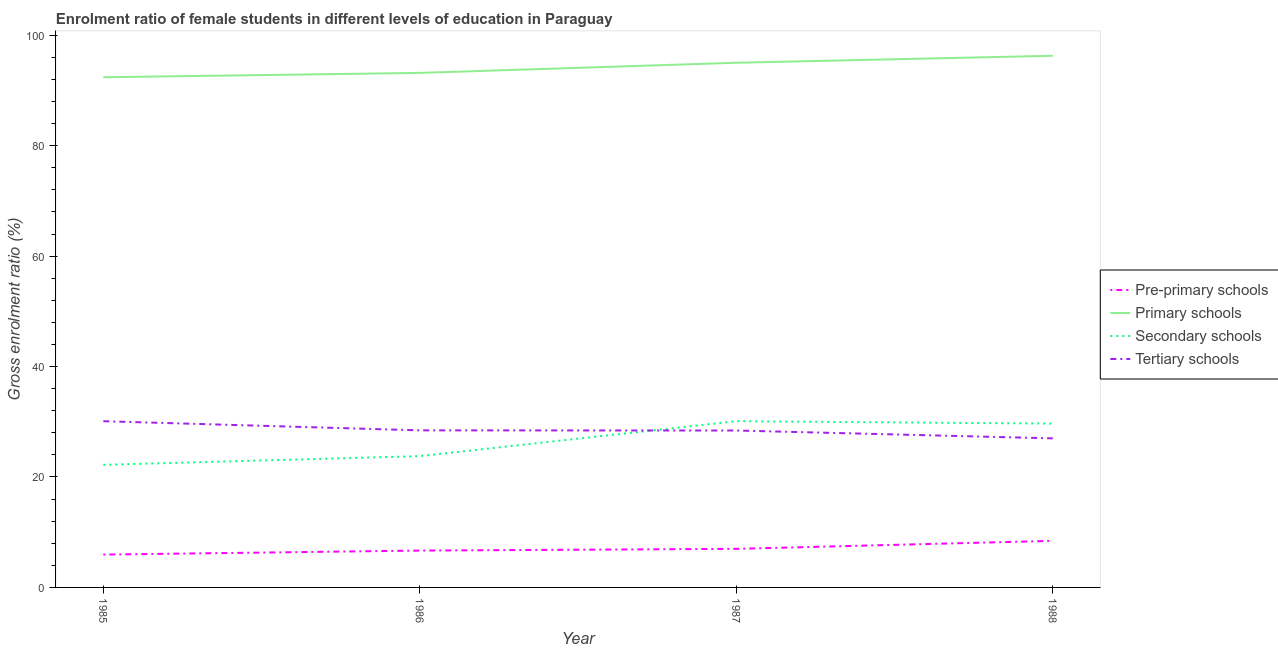How many different coloured lines are there?
Keep it short and to the point. 4. Does the line corresponding to gross enrolment ratio(male) in pre-primary schools intersect with the line corresponding to gross enrolment ratio(male) in tertiary schools?
Provide a short and direct response. No. Is the number of lines equal to the number of legend labels?
Make the answer very short. Yes. What is the gross enrolment ratio(male) in primary schools in 1985?
Give a very brief answer. 92.39. Across all years, what is the maximum gross enrolment ratio(male) in secondary schools?
Keep it short and to the point. 30.11. Across all years, what is the minimum gross enrolment ratio(male) in pre-primary schools?
Give a very brief answer. 5.95. In which year was the gross enrolment ratio(male) in secondary schools maximum?
Ensure brevity in your answer.  1987. What is the total gross enrolment ratio(male) in pre-primary schools in the graph?
Ensure brevity in your answer.  28.04. What is the difference between the gross enrolment ratio(male) in primary schools in 1985 and that in 1987?
Ensure brevity in your answer.  -2.62. What is the difference between the gross enrolment ratio(male) in tertiary schools in 1985 and the gross enrolment ratio(male) in primary schools in 1986?
Give a very brief answer. -63.08. What is the average gross enrolment ratio(male) in tertiary schools per year?
Your answer should be compact. 28.49. In the year 1988, what is the difference between the gross enrolment ratio(male) in secondary schools and gross enrolment ratio(male) in tertiary schools?
Your response must be concise. 2.67. In how many years, is the gross enrolment ratio(male) in primary schools greater than 96 %?
Ensure brevity in your answer.  1. What is the ratio of the gross enrolment ratio(male) in primary schools in 1985 to that in 1988?
Offer a terse response. 0.96. Is the difference between the gross enrolment ratio(male) in secondary schools in 1986 and 1988 greater than the difference between the gross enrolment ratio(male) in pre-primary schools in 1986 and 1988?
Provide a short and direct response. No. What is the difference between the highest and the second highest gross enrolment ratio(male) in secondary schools?
Provide a succinct answer. 0.44. What is the difference between the highest and the lowest gross enrolment ratio(male) in primary schools?
Provide a succinct answer. 3.89. Is the sum of the gross enrolment ratio(male) in pre-primary schools in 1987 and 1988 greater than the maximum gross enrolment ratio(male) in primary schools across all years?
Provide a succinct answer. No. Is it the case that in every year, the sum of the gross enrolment ratio(male) in pre-primary schools and gross enrolment ratio(male) in primary schools is greater than the gross enrolment ratio(male) in secondary schools?
Keep it short and to the point. Yes. Does the gross enrolment ratio(male) in secondary schools monotonically increase over the years?
Ensure brevity in your answer.  No. Is the gross enrolment ratio(male) in secondary schools strictly greater than the gross enrolment ratio(male) in tertiary schools over the years?
Your answer should be compact. No. How many lines are there?
Your answer should be very brief. 4. What is the difference between two consecutive major ticks on the Y-axis?
Give a very brief answer. 20. Does the graph contain any zero values?
Keep it short and to the point. No. Where does the legend appear in the graph?
Your response must be concise. Center right. How many legend labels are there?
Give a very brief answer. 4. What is the title of the graph?
Provide a succinct answer. Enrolment ratio of female students in different levels of education in Paraguay. Does "Primary schools" appear as one of the legend labels in the graph?
Keep it short and to the point. Yes. What is the label or title of the X-axis?
Make the answer very short. Year. What is the Gross enrolment ratio (%) of Pre-primary schools in 1985?
Provide a succinct answer. 5.95. What is the Gross enrolment ratio (%) of Primary schools in 1985?
Offer a terse response. 92.39. What is the Gross enrolment ratio (%) of Secondary schools in 1985?
Keep it short and to the point. 22.2. What is the Gross enrolment ratio (%) of Tertiary schools in 1985?
Provide a succinct answer. 30.1. What is the Gross enrolment ratio (%) of Pre-primary schools in 1986?
Your answer should be very brief. 6.67. What is the Gross enrolment ratio (%) of Primary schools in 1986?
Your answer should be compact. 93.18. What is the Gross enrolment ratio (%) in Secondary schools in 1986?
Your answer should be very brief. 23.78. What is the Gross enrolment ratio (%) in Tertiary schools in 1986?
Give a very brief answer. 28.44. What is the Gross enrolment ratio (%) of Pre-primary schools in 1987?
Keep it short and to the point. 6.99. What is the Gross enrolment ratio (%) in Primary schools in 1987?
Give a very brief answer. 95.02. What is the Gross enrolment ratio (%) of Secondary schools in 1987?
Give a very brief answer. 30.11. What is the Gross enrolment ratio (%) in Tertiary schools in 1987?
Give a very brief answer. 28.42. What is the Gross enrolment ratio (%) in Pre-primary schools in 1988?
Provide a short and direct response. 8.44. What is the Gross enrolment ratio (%) in Primary schools in 1988?
Keep it short and to the point. 96.28. What is the Gross enrolment ratio (%) in Secondary schools in 1988?
Offer a very short reply. 29.67. What is the Gross enrolment ratio (%) of Tertiary schools in 1988?
Provide a succinct answer. 27. Across all years, what is the maximum Gross enrolment ratio (%) in Pre-primary schools?
Your answer should be compact. 8.44. Across all years, what is the maximum Gross enrolment ratio (%) of Primary schools?
Provide a succinct answer. 96.28. Across all years, what is the maximum Gross enrolment ratio (%) of Secondary schools?
Keep it short and to the point. 30.11. Across all years, what is the maximum Gross enrolment ratio (%) in Tertiary schools?
Ensure brevity in your answer.  30.1. Across all years, what is the minimum Gross enrolment ratio (%) in Pre-primary schools?
Ensure brevity in your answer.  5.95. Across all years, what is the minimum Gross enrolment ratio (%) in Primary schools?
Your answer should be very brief. 92.39. Across all years, what is the minimum Gross enrolment ratio (%) in Secondary schools?
Your answer should be compact. 22.2. Across all years, what is the minimum Gross enrolment ratio (%) in Tertiary schools?
Give a very brief answer. 27. What is the total Gross enrolment ratio (%) of Pre-primary schools in the graph?
Give a very brief answer. 28.04. What is the total Gross enrolment ratio (%) of Primary schools in the graph?
Make the answer very short. 376.87. What is the total Gross enrolment ratio (%) in Secondary schools in the graph?
Your response must be concise. 105.76. What is the total Gross enrolment ratio (%) in Tertiary schools in the graph?
Give a very brief answer. 113.96. What is the difference between the Gross enrolment ratio (%) of Pre-primary schools in 1985 and that in 1986?
Provide a succinct answer. -0.73. What is the difference between the Gross enrolment ratio (%) of Primary schools in 1985 and that in 1986?
Your answer should be compact. -0.78. What is the difference between the Gross enrolment ratio (%) in Secondary schools in 1985 and that in 1986?
Ensure brevity in your answer.  -1.58. What is the difference between the Gross enrolment ratio (%) of Tertiary schools in 1985 and that in 1986?
Give a very brief answer. 1.66. What is the difference between the Gross enrolment ratio (%) in Pre-primary schools in 1985 and that in 1987?
Keep it short and to the point. -1.04. What is the difference between the Gross enrolment ratio (%) in Primary schools in 1985 and that in 1987?
Provide a succinct answer. -2.62. What is the difference between the Gross enrolment ratio (%) of Secondary schools in 1985 and that in 1987?
Offer a very short reply. -7.9. What is the difference between the Gross enrolment ratio (%) in Tertiary schools in 1985 and that in 1987?
Your answer should be compact. 1.69. What is the difference between the Gross enrolment ratio (%) of Pre-primary schools in 1985 and that in 1988?
Make the answer very short. -2.49. What is the difference between the Gross enrolment ratio (%) in Primary schools in 1985 and that in 1988?
Ensure brevity in your answer.  -3.89. What is the difference between the Gross enrolment ratio (%) of Secondary schools in 1985 and that in 1988?
Keep it short and to the point. -7.47. What is the difference between the Gross enrolment ratio (%) of Tertiary schools in 1985 and that in 1988?
Provide a succinct answer. 3.11. What is the difference between the Gross enrolment ratio (%) of Pre-primary schools in 1986 and that in 1987?
Offer a terse response. -0.31. What is the difference between the Gross enrolment ratio (%) in Primary schools in 1986 and that in 1987?
Offer a very short reply. -1.84. What is the difference between the Gross enrolment ratio (%) of Secondary schools in 1986 and that in 1987?
Make the answer very short. -6.33. What is the difference between the Gross enrolment ratio (%) of Tertiary schools in 1986 and that in 1987?
Your response must be concise. 0.03. What is the difference between the Gross enrolment ratio (%) of Pre-primary schools in 1986 and that in 1988?
Offer a terse response. -1.76. What is the difference between the Gross enrolment ratio (%) in Primary schools in 1986 and that in 1988?
Offer a terse response. -3.1. What is the difference between the Gross enrolment ratio (%) of Secondary schools in 1986 and that in 1988?
Your response must be concise. -5.89. What is the difference between the Gross enrolment ratio (%) in Tertiary schools in 1986 and that in 1988?
Offer a terse response. 1.45. What is the difference between the Gross enrolment ratio (%) of Pre-primary schools in 1987 and that in 1988?
Your answer should be very brief. -1.45. What is the difference between the Gross enrolment ratio (%) in Primary schools in 1987 and that in 1988?
Your answer should be compact. -1.26. What is the difference between the Gross enrolment ratio (%) of Secondary schools in 1987 and that in 1988?
Offer a very short reply. 0.44. What is the difference between the Gross enrolment ratio (%) in Tertiary schools in 1987 and that in 1988?
Give a very brief answer. 1.42. What is the difference between the Gross enrolment ratio (%) in Pre-primary schools in 1985 and the Gross enrolment ratio (%) in Primary schools in 1986?
Your answer should be compact. -87.23. What is the difference between the Gross enrolment ratio (%) in Pre-primary schools in 1985 and the Gross enrolment ratio (%) in Secondary schools in 1986?
Make the answer very short. -17.83. What is the difference between the Gross enrolment ratio (%) of Pre-primary schools in 1985 and the Gross enrolment ratio (%) of Tertiary schools in 1986?
Give a very brief answer. -22.5. What is the difference between the Gross enrolment ratio (%) of Primary schools in 1985 and the Gross enrolment ratio (%) of Secondary schools in 1986?
Provide a short and direct response. 68.62. What is the difference between the Gross enrolment ratio (%) of Primary schools in 1985 and the Gross enrolment ratio (%) of Tertiary schools in 1986?
Ensure brevity in your answer.  63.95. What is the difference between the Gross enrolment ratio (%) in Secondary schools in 1985 and the Gross enrolment ratio (%) in Tertiary schools in 1986?
Your response must be concise. -6.24. What is the difference between the Gross enrolment ratio (%) of Pre-primary schools in 1985 and the Gross enrolment ratio (%) of Primary schools in 1987?
Ensure brevity in your answer.  -89.07. What is the difference between the Gross enrolment ratio (%) in Pre-primary schools in 1985 and the Gross enrolment ratio (%) in Secondary schools in 1987?
Make the answer very short. -24.16. What is the difference between the Gross enrolment ratio (%) of Pre-primary schools in 1985 and the Gross enrolment ratio (%) of Tertiary schools in 1987?
Ensure brevity in your answer.  -22.47. What is the difference between the Gross enrolment ratio (%) of Primary schools in 1985 and the Gross enrolment ratio (%) of Secondary schools in 1987?
Your response must be concise. 62.29. What is the difference between the Gross enrolment ratio (%) in Primary schools in 1985 and the Gross enrolment ratio (%) in Tertiary schools in 1987?
Ensure brevity in your answer.  63.98. What is the difference between the Gross enrolment ratio (%) in Secondary schools in 1985 and the Gross enrolment ratio (%) in Tertiary schools in 1987?
Offer a very short reply. -6.21. What is the difference between the Gross enrolment ratio (%) in Pre-primary schools in 1985 and the Gross enrolment ratio (%) in Primary schools in 1988?
Your answer should be compact. -90.34. What is the difference between the Gross enrolment ratio (%) of Pre-primary schools in 1985 and the Gross enrolment ratio (%) of Secondary schools in 1988?
Keep it short and to the point. -23.72. What is the difference between the Gross enrolment ratio (%) of Pre-primary schools in 1985 and the Gross enrolment ratio (%) of Tertiary schools in 1988?
Ensure brevity in your answer.  -21.05. What is the difference between the Gross enrolment ratio (%) of Primary schools in 1985 and the Gross enrolment ratio (%) of Secondary schools in 1988?
Ensure brevity in your answer.  62.73. What is the difference between the Gross enrolment ratio (%) in Primary schools in 1985 and the Gross enrolment ratio (%) in Tertiary schools in 1988?
Your answer should be very brief. 65.4. What is the difference between the Gross enrolment ratio (%) of Secondary schools in 1985 and the Gross enrolment ratio (%) of Tertiary schools in 1988?
Provide a short and direct response. -4.79. What is the difference between the Gross enrolment ratio (%) in Pre-primary schools in 1986 and the Gross enrolment ratio (%) in Primary schools in 1987?
Provide a succinct answer. -88.34. What is the difference between the Gross enrolment ratio (%) of Pre-primary schools in 1986 and the Gross enrolment ratio (%) of Secondary schools in 1987?
Keep it short and to the point. -23.43. What is the difference between the Gross enrolment ratio (%) in Pre-primary schools in 1986 and the Gross enrolment ratio (%) in Tertiary schools in 1987?
Your response must be concise. -21.74. What is the difference between the Gross enrolment ratio (%) of Primary schools in 1986 and the Gross enrolment ratio (%) of Secondary schools in 1987?
Make the answer very short. 63.07. What is the difference between the Gross enrolment ratio (%) in Primary schools in 1986 and the Gross enrolment ratio (%) in Tertiary schools in 1987?
Ensure brevity in your answer.  64.76. What is the difference between the Gross enrolment ratio (%) in Secondary schools in 1986 and the Gross enrolment ratio (%) in Tertiary schools in 1987?
Your answer should be very brief. -4.64. What is the difference between the Gross enrolment ratio (%) in Pre-primary schools in 1986 and the Gross enrolment ratio (%) in Primary schools in 1988?
Offer a terse response. -89.61. What is the difference between the Gross enrolment ratio (%) in Pre-primary schools in 1986 and the Gross enrolment ratio (%) in Secondary schools in 1988?
Give a very brief answer. -22.99. What is the difference between the Gross enrolment ratio (%) in Pre-primary schools in 1986 and the Gross enrolment ratio (%) in Tertiary schools in 1988?
Provide a succinct answer. -20.32. What is the difference between the Gross enrolment ratio (%) of Primary schools in 1986 and the Gross enrolment ratio (%) of Secondary schools in 1988?
Your response must be concise. 63.51. What is the difference between the Gross enrolment ratio (%) in Primary schools in 1986 and the Gross enrolment ratio (%) in Tertiary schools in 1988?
Make the answer very short. 66.18. What is the difference between the Gross enrolment ratio (%) of Secondary schools in 1986 and the Gross enrolment ratio (%) of Tertiary schools in 1988?
Give a very brief answer. -3.22. What is the difference between the Gross enrolment ratio (%) in Pre-primary schools in 1987 and the Gross enrolment ratio (%) in Primary schools in 1988?
Offer a terse response. -89.3. What is the difference between the Gross enrolment ratio (%) of Pre-primary schools in 1987 and the Gross enrolment ratio (%) of Secondary schools in 1988?
Give a very brief answer. -22.68. What is the difference between the Gross enrolment ratio (%) of Pre-primary schools in 1987 and the Gross enrolment ratio (%) of Tertiary schools in 1988?
Your answer should be compact. -20.01. What is the difference between the Gross enrolment ratio (%) in Primary schools in 1987 and the Gross enrolment ratio (%) in Secondary schools in 1988?
Your answer should be compact. 65.35. What is the difference between the Gross enrolment ratio (%) in Primary schools in 1987 and the Gross enrolment ratio (%) in Tertiary schools in 1988?
Provide a short and direct response. 68.02. What is the difference between the Gross enrolment ratio (%) of Secondary schools in 1987 and the Gross enrolment ratio (%) of Tertiary schools in 1988?
Provide a short and direct response. 3.11. What is the average Gross enrolment ratio (%) of Pre-primary schools per year?
Your answer should be compact. 7.01. What is the average Gross enrolment ratio (%) of Primary schools per year?
Keep it short and to the point. 94.22. What is the average Gross enrolment ratio (%) of Secondary schools per year?
Your answer should be very brief. 26.44. What is the average Gross enrolment ratio (%) of Tertiary schools per year?
Your response must be concise. 28.49. In the year 1985, what is the difference between the Gross enrolment ratio (%) of Pre-primary schools and Gross enrolment ratio (%) of Primary schools?
Offer a very short reply. -86.45. In the year 1985, what is the difference between the Gross enrolment ratio (%) in Pre-primary schools and Gross enrolment ratio (%) in Secondary schools?
Keep it short and to the point. -16.26. In the year 1985, what is the difference between the Gross enrolment ratio (%) in Pre-primary schools and Gross enrolment ratio (%) in Tertiary schools?
Your answer should be compact. -24.16. In the year 1985, what is the difference between the Gross enrolment ratio (%) in Primary schools and Gross enrolment ratio (%) in Secondary schools?
Provide a succinct answer. 70.19. In the year 1985, what is the difference between the Gross enrolment ratio (%) in Primary schools and Gross enrolment ratio (%) in Tertiary schools?
Provide a succinct answer. 62.29. In the year 1985, what is the difference between the Gross enrolment ratio (%) of Secondary schools and Gross enrolment ratio (%) of Tertiary schools?
Provide a succinct answer. -7.9. In the year 1986, what is the difference between the Gross enrolment ratio (%) in Pre-primary schools and Gross enrolment ratio (%) in Primary schools?
Ensure brevity in your answer.  -86.5. In the year 1986, what is the difference between the Gross enrolment ratio (%) of Pre-primary schools and Gross enrolment ratio (%) of Secondary schools?
Your answer should be very brief. -17.1. In the year 1986, what is the difference between the Gross enrolment ratio (%) in Pre-primary schools and Gross enrolment ratio (%) in Tertiary schools?
Make the answer very short. -21.77. In the year 1986, what is the difference between the Gross enrolment ratio (%) in Primary schools and Gross enrolment ratio (%) in Secondary schools?
Ensure brevity in your answer.  69.4. In the year 1986, what is the difference between the Gross enrolment ratio (%) of Primary schools and Gross enrolment ratio (%) of Tertiary schools?
Make the answer very short. 64.73. In the year 1986, what is the difference between the Gross enrolment ratio (%) in Secondary schools and Gross enrolment ratio (%) in Tertiary schools?
Your answer should be very brief. -4.67. In the year 1987, what is the difference between the Gross enrolment ratio (%) of Pre-primary schools and Gross enrolment ratio (%) of Primary schools?
Provide a succinct answer. -88.03. In the year 1987, what is the difference between the Gross enrolment ratio (%) in Pre-primary schools and Gross enrolment ratio (%) in Secondary schools?
Provide a succinct answer. -23.12. In the year 1987, what is the difference between the Gross enrolment ratio (%) in Pre-primary schools and Gross enrolment ratio (%) in Tertiary schools?
Your answer should be very brief. -21.43. In the year 1987, what is the difference between the Gross enrolment ratio (%) in Primary schools and Gross enrolment ratio (%) in Secondary schools?
Give a very brief answer. 64.91. In the year 1987, what is the difference between the Gross enrolment ratio (%) in Primary schools and Gross enrolment ratio (%) in Tertiary schools?
Make the answer very short. 66.6. In the year 1987, what is the difference between the Gross enrolment ratio (%) in Secondary schools and Gross enrolment ratio (%) in Tertiary schools?
Your response must be concise. 1.69. In the year 1988, what is the difference between the Gross enrolment ratio (%) of Pre-primary schools and Gross enrolment ratio (%) of Primary schools?
Provide a short and direct response. -87.85. In the year 1988, what is the difference between the Gross enrolment ratio (%) of Pre-primary schools and Gross enrolment ratio (%) of Secondary schools?
Offer a very short reply. -21.23. In the year 1988, what is the difference between the Gross enrolment ratio (%) of Pre-primary schools and Gross enrolment ratio (%) of Tertiary schools?
Your answer should be very brief. -18.56. In the year 1988, what is the difference between the Gross enrolment ratio (%) in Primary schools and Gross enrolment ratio (%) in Secondary schools?
Your response must be concise. 66.61. In the year 1988, what is the difference between the Gross enrolment ratio (%) in Primary schools and Gross enrolment ratio (%) in Tertiary schools?
Offer a very short reply. 69.29. In the year 1988, what is the difference between the Gross enrolment ratio (%) of Secondary schools and Gross enrolment ratio (%) of Tertiary schools?
Provide a short and direct response. 2.67. What is the ratio of the Gross enrolment ratio (%) of Pre-primary schools in 1985 to that in 1986?
Keep it short and to the point. 0.89. What is the ratio of the Gross enrolment ratio (%) in Primary schools in 1985 to that in 1986?
Provide a succinct answer. 0.99. What is the ratio of the Gross enrolment ratio (%) in Secondary schools in 1985 to that in 1986?
Make the answer very short. 0.93. What is the ratio of the Gross enrolment ratio (%) in Tertiary schools in 1985 to that in 1986?
Make the answer very short. 1.06. What is the ratio of the Gross enrolment ratio (%) in Pre-primary schools in 1985 to that in 1987?
Keep it short and to the point. 0.85. What is the ratio of the Gross enrolment ratio (%) in Primary schools in 1985 to that in 1987?
Your answer should be very brief. 0.97. What is the ratio of the Gross enrolment ratio (%) of Secondary schools in 1985 to that in 1987?
Offer a terse response. 0.74. What is the ratio of the Gross enrolment ratio (%) of Tertiary schools in 1985 to that in 1987?
Provide a short and direct response. 1.06. What is the ratio of the Gross enrolment ratio (%) in Pre-primary schools in 1985 to that in 1988?
Offer a terse response. 0.7. What is the ratio of the Gross enrolment ratio (%) in Primary schools in 1985 to that in 1988?
Offer a terse response. 0.96. What is the ratio of the Gross enrolment ratio (%) in Secondary schools in 1985 to that in 1988?
Offer a very short reply. 0.75. What is the ratio of the Gross enrolment ratio (%) of Tertiary schools in 1985 to that in 1988?
Provide a succinct answer. 1.12. What is the ratio of the Gross enrolment ratio (%) of Pre-primary schools in 1986 to that in 1987?
Offer a terse response. 0.96. What is the ratio of the Gross enrolment ratio (%) in Primary schools in 1986 to that in 1987?
Your response must be concise. 0.98. What is the ratio of the Gross enrolment ratio (%) of Secondary schools in 1986 to that in 1987?
Provide a succinct answer. 0.79. What is the ratio of the Gross enrolment ratio (%) of Tertiary schools in 1986 to that in 1987?
Offer a very short reply. 1. What is the ratio of the Gross enrolment ratio (%) in Pre-primary schools in 1986 to that in 1988?
Keep it short and to the point. 0.79. What is the ratio of the Gross enrolment ratio (%) in Primary schools in 1986 to that in 1988?
Offer a very short reply. 0.97. What is the ratio of the Gross enrolment ratio (%) of Secondary schools in 1986 to that in 1988?
Your answer should be compact. 0.8. What is the ratio of the Gross enrolment ratio (%) in Tertiary schools in 1986 to that in 1988?
Keep it short and to the point. 1.05. What is the ratio of the Gross enrolment ratio (%) of Pre-primary schools in 1987 to that in 1988?
Provide a short and direct response. 0.83. What is the ratio of the Gross enrolment ratio (%) in Primary schools in 1987 to that in 1988?
Provide a short and direct response. 0.99. What is the ratio of the Gross enrolment ratio (%) of Secondary schools in 1987 to that in 1988?
Give a very brief answer. 1.01. What is the ratio of the Gross enrolment ratio (%) in Tertiary schools in 1987 to that in 1988?
Provide a succinct answer. 1.05. What is the difference between the highest and the second highest Gross enrolment ratio (%) in Pre-primary schools?
Provide a succinct answer. 1.45. What is the difference between the highest and the second highest Gross enrolment ratio (%) of Primary schools?
Provide a short and direct response. 1.26. What is the difference between the highest and the second highest Gross enrolment ratio (%) of Secondary schools?
Keep it short and to the point. 0.44. What is the difference between the highest and the second highest Gross enrolment ratio (%) in Tertiary schools?
Make the answer very short. 1.66. What is the difference between the highest and the lowest Gross enrolment ratio (%) in Pre-primary schools?
Ensure brevity in your answer.  2.49. What is the difference between the highest and the lowest Gross enrolment ratio (%) of Primary schools?
Your answer should be very brief. 3.89. What is the difference between the highest and the lowest Gross enrolment ratio (%) of Secondary schools?
Provide a succinct answer. 7.9. What is the difference between the highest and the lowest Gross enrolment ratio (%) in Tertiary schools?
Your answer should be compact. 3.11. 